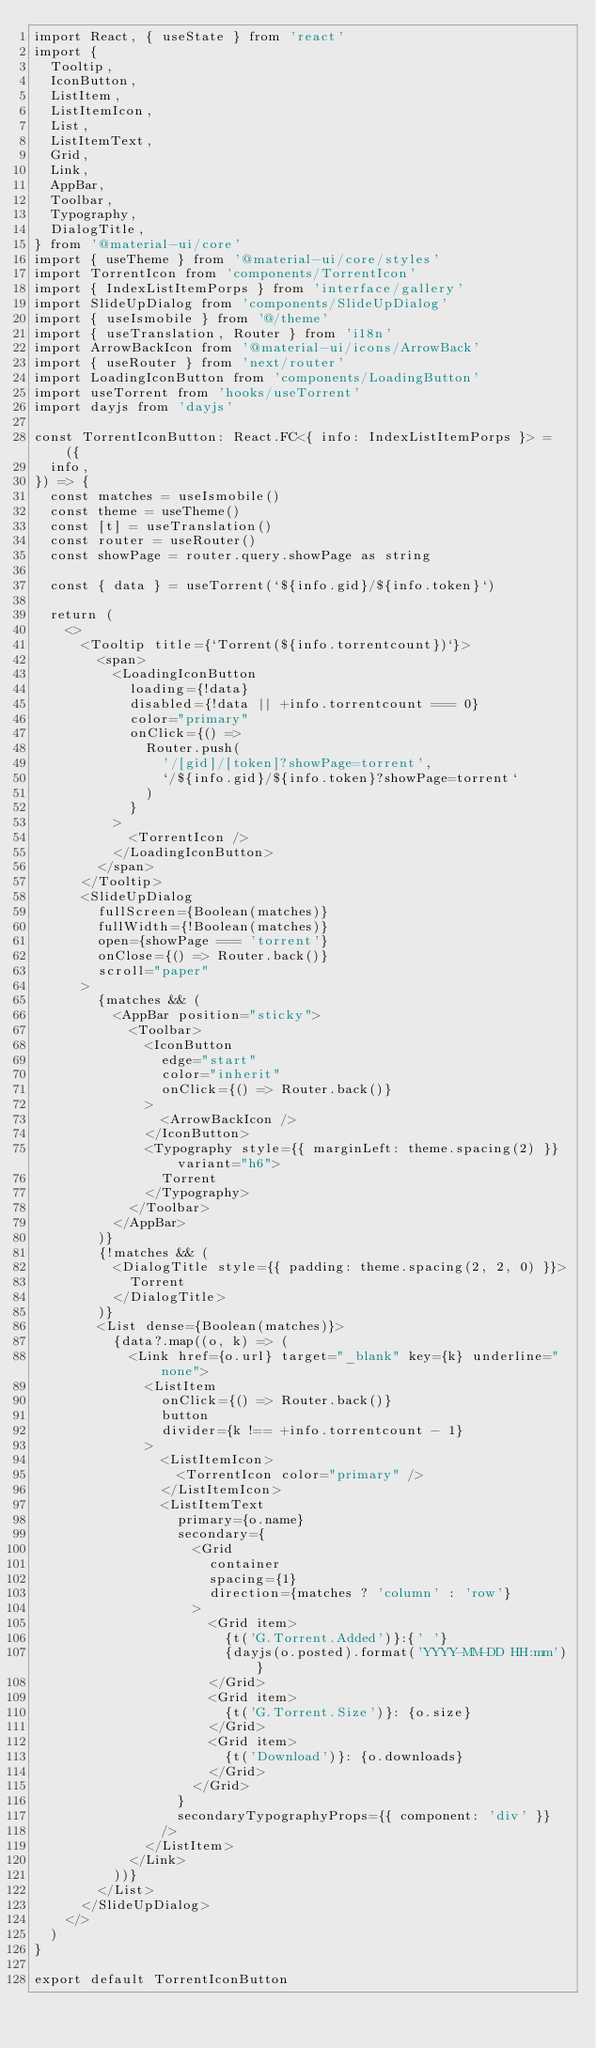<code> <loc_0><loc_0><loc_500><loc_500><_TypeScript_>import React, { useState } from 'react'
import {
  Tooltip,
  IconButton,
  ListItem,
  ListItemIcon,
  List,
  ListItemText,
  Grid,
  Link,
  AppBar,
  Toolbar,
  Typography,
  DialogTitle,
} from '@material-ui/core'
import { useTheme } from '@material-ui/core/styles'
import TorrentIcon from 'components/TorrentIcon'
import { IndexListItemPorps } from 'interface/gallery'
import SlideUpDialog from 'components/SlideUpDialog'
import { useIsmobile } from '@/theme'
import { useTranslation, Router } from 'i18n'
import ArrowBackIcon from '@material-ui/icons/ArrowBack'
import { useRouter } from 'next/router'
import LoadingIconButton from 'components/LoadingButton'
import useTorrent from 'hooks/useTorrent'
import dayjs from 'dayjs'

const TorrentIconButton: React.FC<{ info: IndexListItemPorps }> = ({
  info,
}) => {
  const matches = useIsmobile()
  const theme = useTheme()
  const [t] = useTranslation()
  const router = useRouter()
  const showPage = router.query.showPage as string

  const { data } = useTorrent(`${info.gid}/${info.token}`)

  return (
    <>
      <Tooltip title={`Torrent(${info.torrentcount})`}>
        <span>
          <LoadingIconButton
            loading={!data}
            disabled={!data || +info.torrentcount === 0}
            color="primary"
            onClick={() =>
              Router.push(
                '/[gid]/[token]?showPage=torrent',
                `/${info.gid}/${info.token}?showPage=torrent`
              )
            }
          >
            <TorrentIcon />
          </LoadingIconButton>
        </span>
      </Tooltip>
      <SlideUpDialog
        fullScreen={Boolean(matches)}
        fullWidth={!Boolean(matches)}
        open={showPage === 'torrent'}
        onClose={() => Router.back()}
        scroll="paper"
      >
        {matches && (
          <AppBar position="sticky">
            <Toolbar>
              <IconButton
                edge="start"
                color="inherit"
                onClick={() => Router.back()}
              >
                <ArrowBackIcon />
              </IconButton>
              <Typography style={{ marginLeft: theme.spacing(2) }} variant="h6">
                Torrent
              </Typography>
            </Toolbar>
          </AppBar>
        )}
        {!matches && (
          <DialogTitle style={{ padding: theme.spacing(2, 2, 0) }}>
            Torrent
          </DialogTitle>
        )}
        <List dense={Boolean(matches)}>
          {data?.map((o, k) => (
            <Link href={o.url} target="_blank" key={k} underline="none">
              <ListItem
                onClick={() => Router.back()}
                button
                divider={k !== +info.torrentcount - 1}
              >
                <ListItemIcon>
                  <TorrentIcon color="primary" />
                </ListItemIcon>
                <ListItemText
                  primary={o.name}
                  secondary={
                    <Grid
                      container
                      spacing={1}
                      direction={matches ? 'column' : 'row'}
                    >
                      <Grid item>
                        {t('G.Torrent.Added')}:{' '}
                        {dayjs(o.posted).format('YYYY-MM-DD HH:mm')}
                      </Grid>
                      <Grid item>
                        {t('G.Torrent.Size')}: {o.size}
                      </Grid>
                      <Grid item>
                        {t('Download')}: {o.downloads}
                      </Grid>
                    </Grid>
                  }
                  secondaryTypographyProps={{ component: 'div' }}
                />
              </ListItem>
            </Link>
          ))}
        </List>
      </SlideUpDialog>
    </>
  )
}

export default TorrentIconButton
</code> 